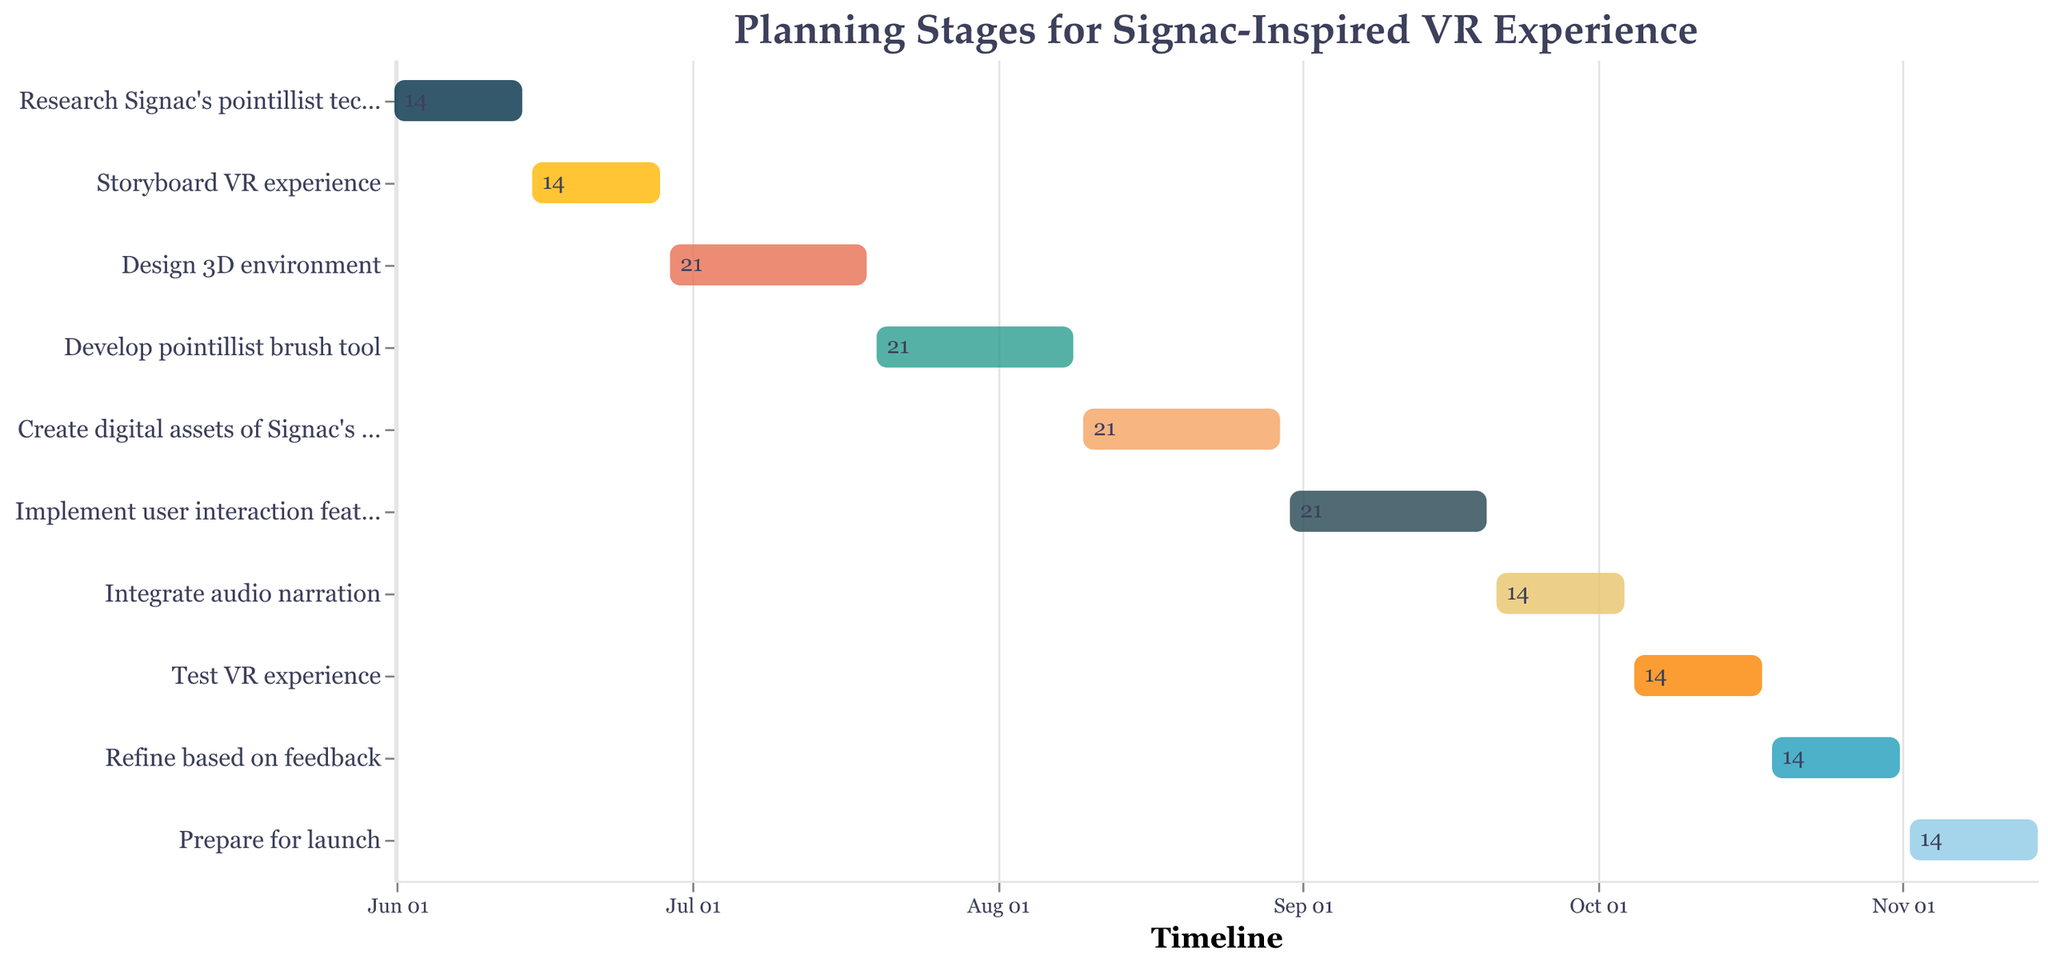Which task has the shortest duration? Look at the visual lengths of the bars representing the tasks and compare them. The task "Research Signac's pointillist technique" has the shortest duration of 14 days.
Answer: Research Signac's pointillist technique What is the total duration for designing and developing phases combined? Combine the durations of "Design 3D environment" (21 days) and "Develop pointillist brush tool" (21 days). Sum is 21 + 21 = 42 days.
Answer: 42 days Which task ends immediately before "Integrate audio narration"? Find the end date of "Implement user interaction features," which is 2023-09-20, just before "Integrate audio narration" starts on 2023-09-21.
Answer: Implement user interaction features Which task overlaps with the creation of digital assets of Signac’s paintings? Identify tasks that occur within 2023-08-10 to 2023-08-30. "Develop pointillist brush tool" overlaps from 2023-07-20 to 2023-08-09, ending right before the given task.
Answer: None How long does it take from starting the first task to completing the project? Calculate the difference between the start date of the first task (2023-06-01) and the end date of the last task (2023-11-15). This consists of June, July, August, September, October, and 15 days of November. Total days = 14 (June) + 31 (July) + 31 (August) + 30 (September) + 31 (October) + 15 (November) = 152 days.
Answer: 152 days Which tasks have the same duration? Compare the durations of all tasks. Tasks with a duration of 14 days include: "Research Signac's pointillist technique," "Storyboard VR experience," "Integrate audio narration," "Test VR experience," "Refine based on feedback," and "Prepare for launch."
Answer: Research Signac's pointillist technique, Storyboard VR experience, Integrate audio narration, Test VR experience, Refine based on feedback, Prepare for launch When does the task with the longest duration start and end? Identify the task with the longest duration. "Design 3D environment," "Develop pointillist brush tool," "Create digital assets of Signac's paintings," and "Implement user interaction features" each last 21 days. The start and end dates of the first of these (Design 3D environment) are 2023-06-29 and 2023-07-19.
Answer: 2023-06-29 to 2023-07-19 Which task starts immediately after the "Storyboard VR experience"? Find the task with a start date immediately following the end date of "Storyboard VR experience" (2023-06-28). "Design 3D environment" starts the next day, 2023-06-29.
Answer: Design 3D environment How many tasks are planned to start in August 2023? Count the tasks with a start date in August 2023: "Create digital assets of Signac's paintings" on 2023-08-10 and "Implement user interaction features" on 2023-08-31. Two tasks start in August.
Answer: 2 tasks What is the average duration of all the tasks? Add all task durations: 14 + 14 + 21 + 21 + 21 + 21 + 14 + 14 + 14 + 14 = 168 days. Divide by the number of tasks (10). The average duration is 168/10 = 16.8 days.
Answer: 16.8 days 